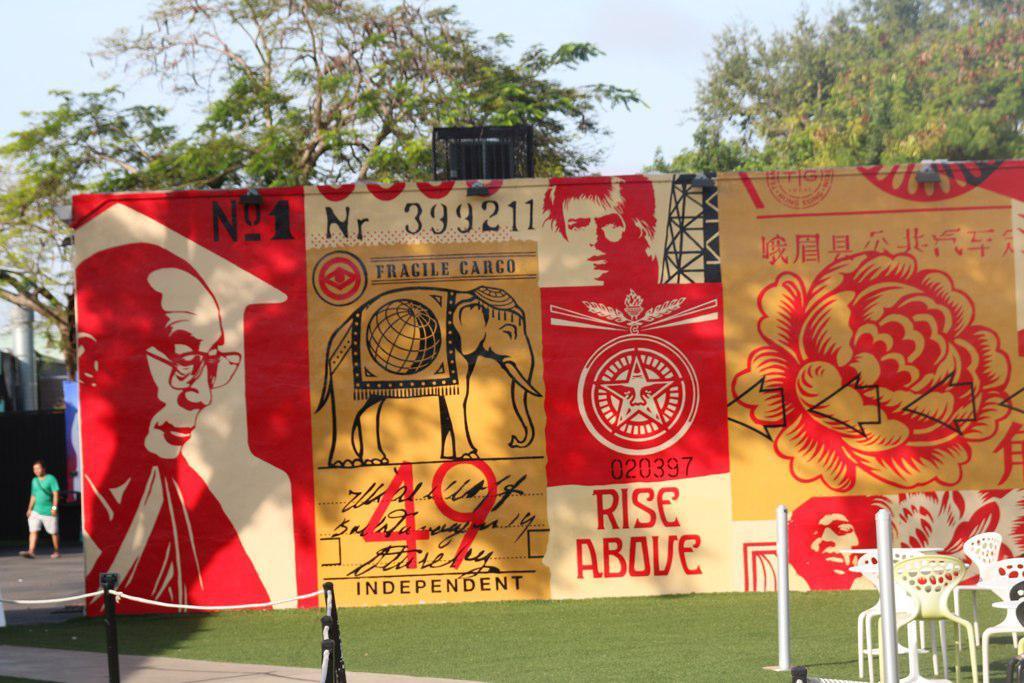Could you give a brief overview of what you see in this image? In this picture I can see there is a banner and there is elephant, a flower and person pictures on the banner and in the background there is a person walking, there are some trees and the sky is clear. 